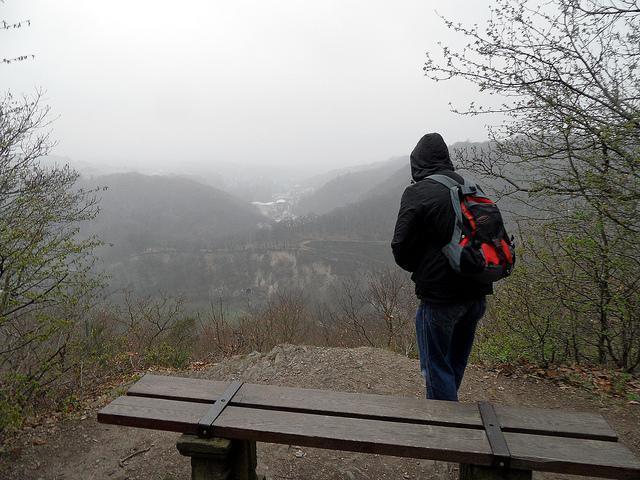What item here can hold the most books?
Pick the correct solution from the four options below to address the question.
Options: Luggage, bookcase, wheelbarrow, backpack. Backpack. 